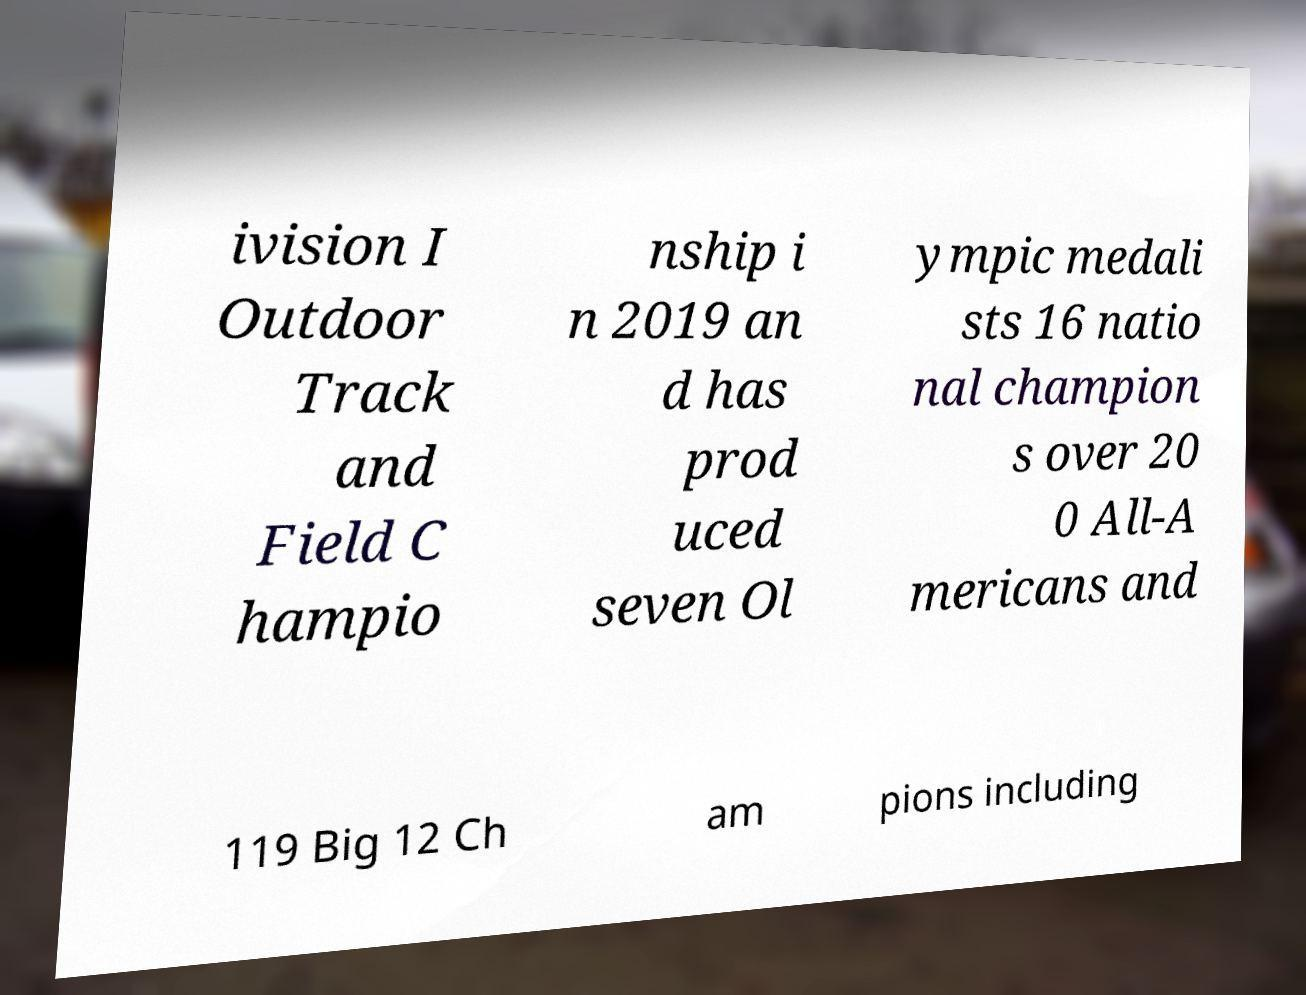Could you extract and type out the text from this image? ivision I Outdoor Track and Field C hampio nship i n 2019 an d has prod uced seven Ol ympic medali sts 16 natio nal champion s over 20 0 All-A mericans and 119 Big 12 Ch am pions including 